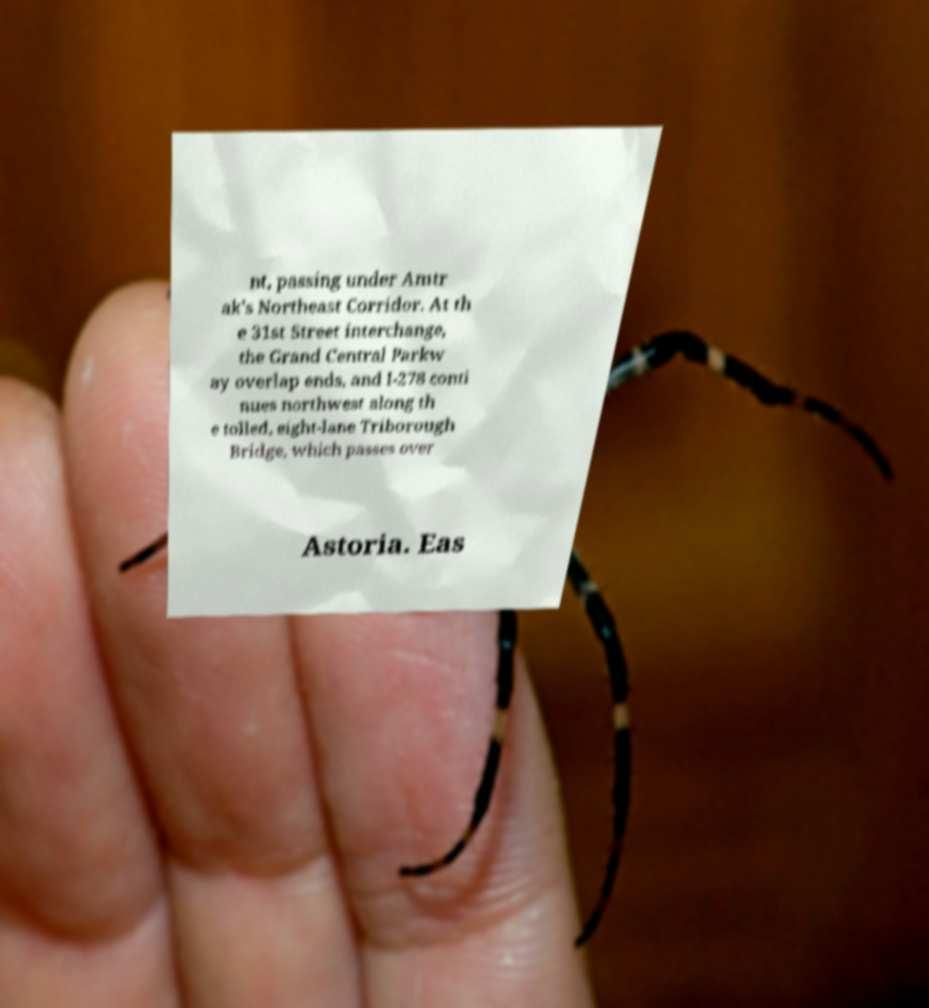Could you extract and type out the text from this image? nt, passing under Amtr ak's Northeast Corridor. At th e 31st Street interchange, the Grand Central Parkw ay overlap ends, and I-278 conti nues northwest along th e tolled, eight-lane Triborough Bridge, which passes over Astoria. Eas 